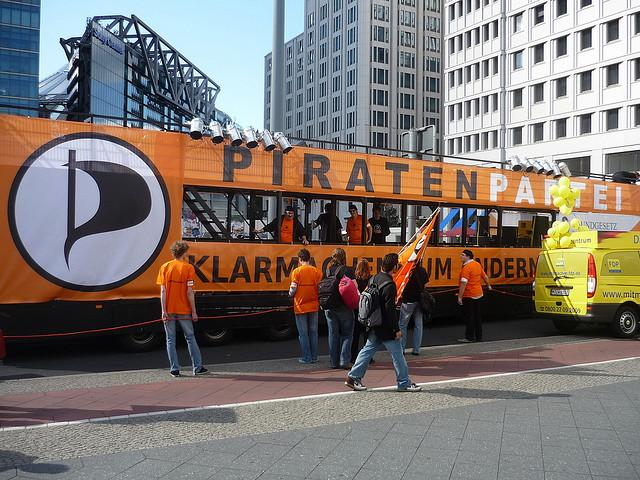What fun item can be seen in the photo? balloons 